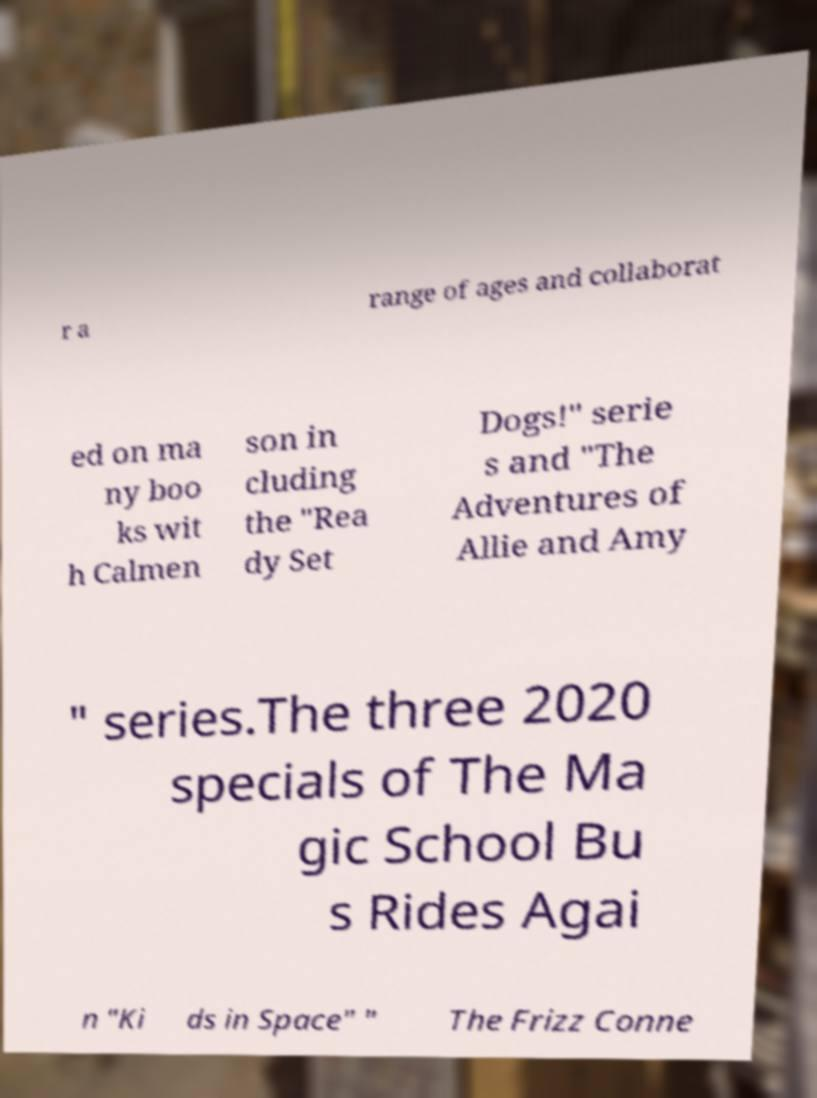Please identify and transcribe the text found in this image. r a range of ages and collaborat ed on ma ny boo ks wit h Calmen son in cluding the "Rea dy Set Dogs!" serie s and "The Adventures of Allie and Amy " series.The three 2020 specials of The Ma gic School Bu s Rides Agai n "Ki ds in Space" " The Frizz Conne 